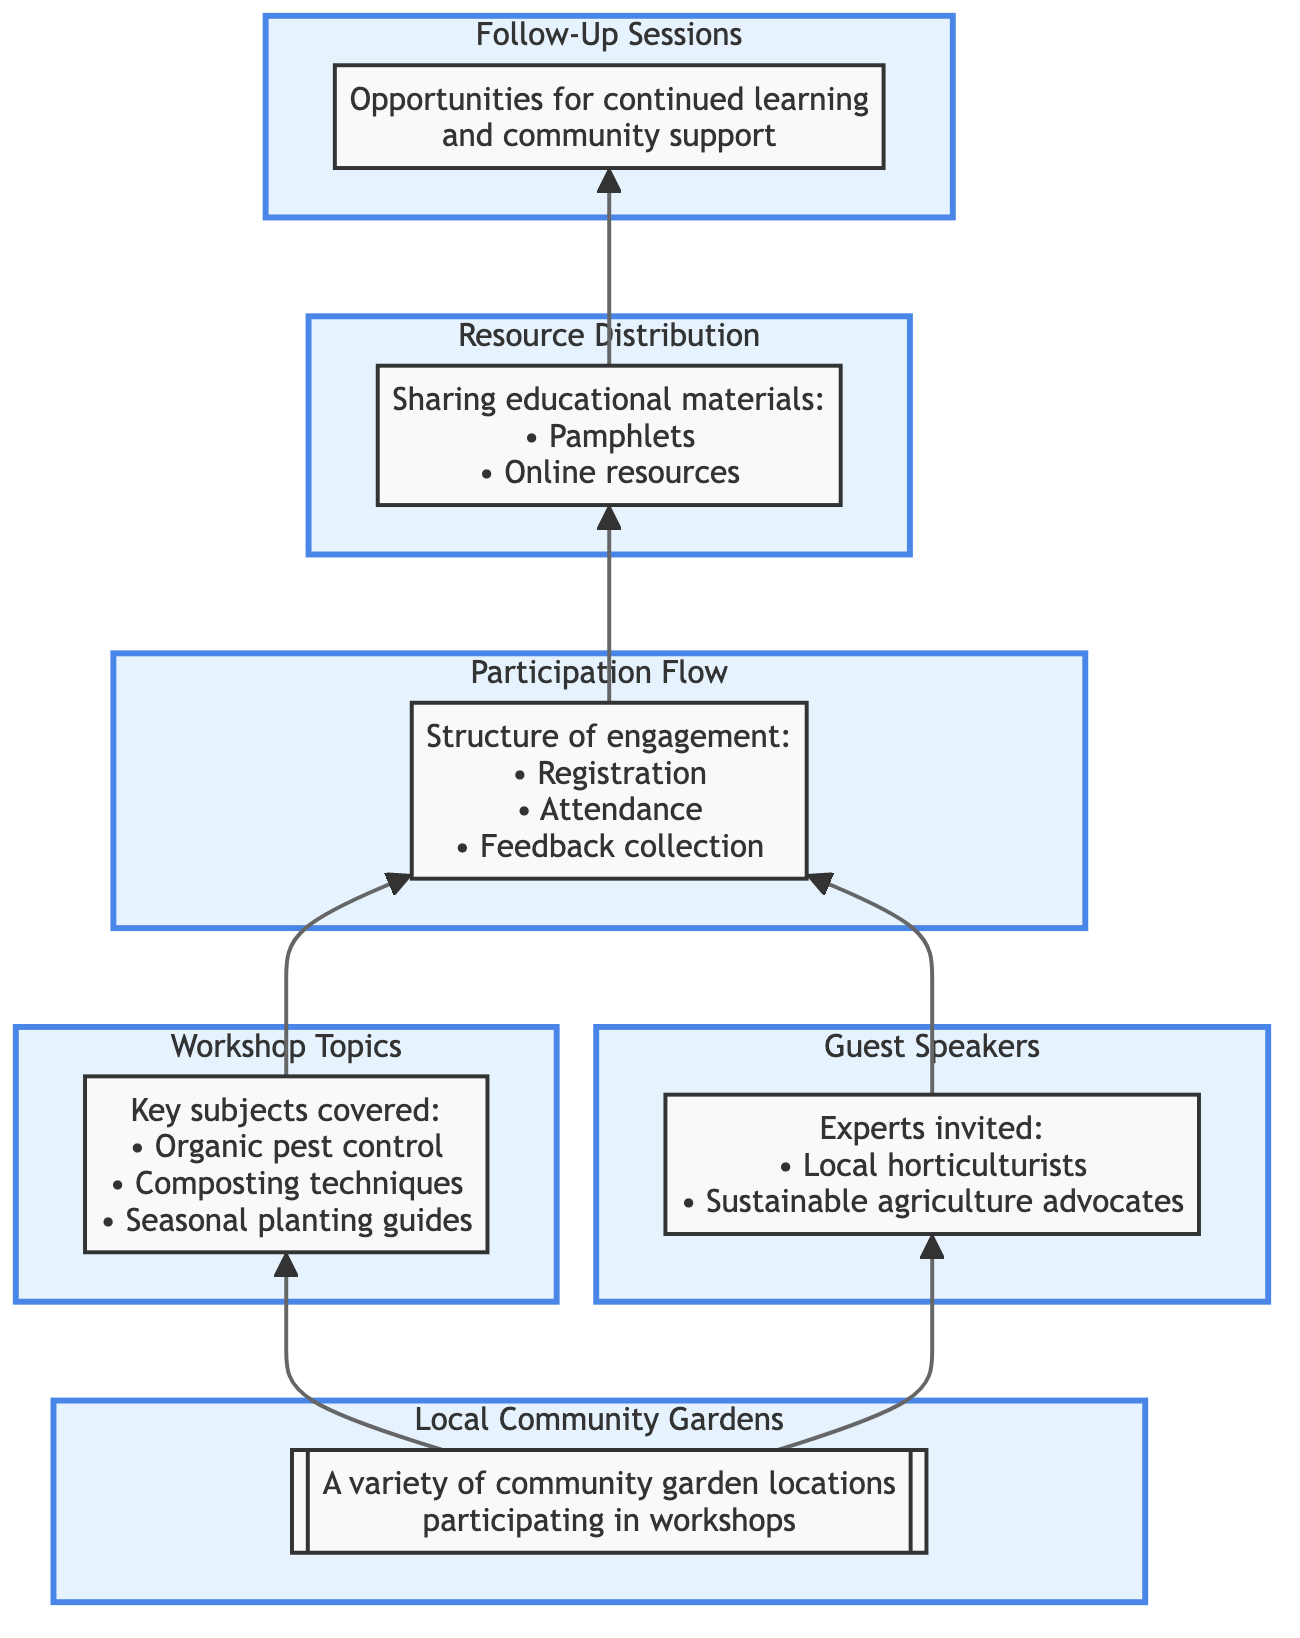What are the key subjects covered in the workshops? The diagram lists several key subjects under the "Workshop Topics" node, specifically organic pest control, composting techniques, and seasonal planting guides.
Answer: Organic pest control, composting techniques, seasonal planting guides How many participants' engagement steps are outlined in the Participation Flow? The "Participation Flow" node details three steps: registration, attendance, and feedback collection, indicating that there are three distinct engagement steps outlined.
Answer: 3 Which node follows the Workshop Topics node in the flow? The flow indicates that the "Participation Flow" node directly follows from the "Workshop Topics" node, highlighting the structure of engagement that comes after discussing the workshop topics.
Answer: Participation Flow What is shared with attendees as part of Resource Distribution? The "Resource Distribution" node specifies that educational materials such as pamphlets and online resources are shared with attendees.
Answer: Pamphlets, online resources What opportunities are provided after the workshops? The "Follow-Up Sessions" node states that these sessions provide opportunities for participants to connect for continued learning and community support, indicating ongoing engagement post-workshop.
Answer: Continued learning, community support What is the starting point for the engagement process? The "Local Community Gardens" node serves as the starting point, as it is the first node from which other subjects, such as workshop topics and guest speakers, flow into the participation structure.
Answer: Local Community Gardens Which node is directly linked to both Guest Speakers and Workshop Topics? The "Participation Flow" node is directly connected both to the "Guest Speakers" and "Workshop Topics" nodes, showing that it encompasses engagement from both sources of knowledge shared in the workshops.
Answer: Participation Flow How does the flow chart illustrate the connection between workshops and resource sharing? The diagram shows that after the "Participation Flow," the next node is "Resource Distribution," indicating that resource sharing comes after participants engage in the workshops.
Answer: Resource Distribution 